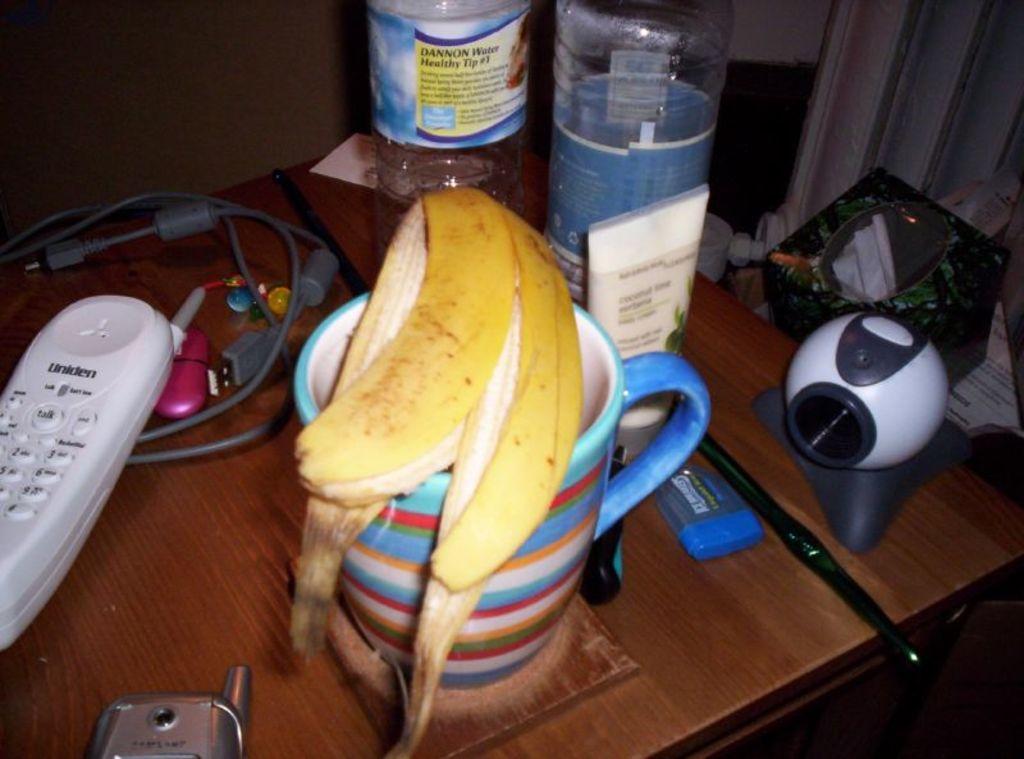Could you give a brief overview of what you see in this image? This picture there is a cup, device, remote, cable, cell phone, bracelet, banana peel and box and there are bottles on the table. At the back there is a wall. 